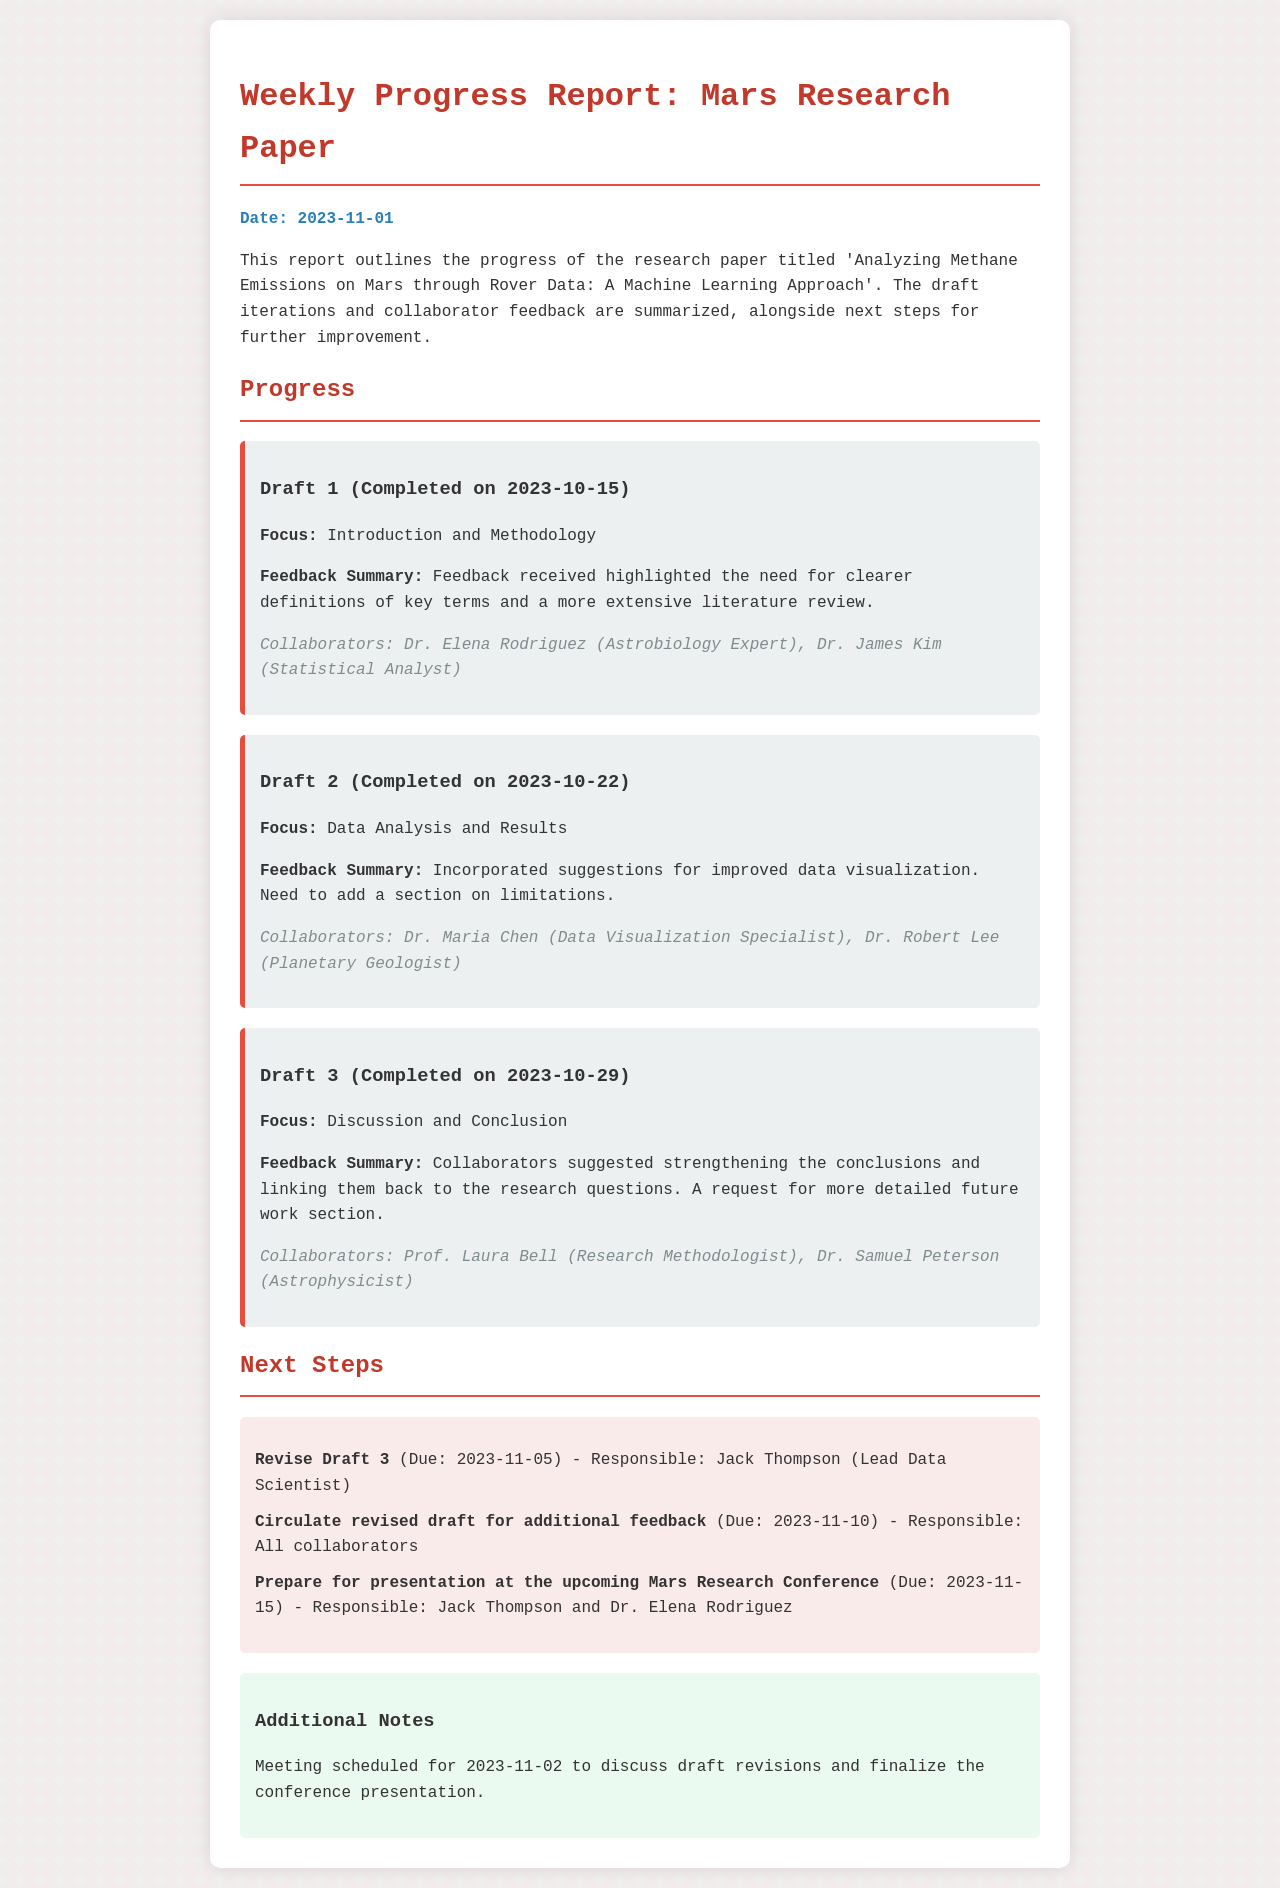What is the title of the research paper? The title is explicitly mentioned at the beginning of the report, which is 'Analyzing Methane Emissions on Mars through Rover Data: A Machine Learning Approach'.
Answer: Analyzing Methane Emissions on Mars through Rover Data: A Machine Learning Approach Who is responsible for revising Draft 3? The responsibility for revising Draft 3 is assigned to Jack Thompson, as noted in the next steps section of the report.
Answer: Jack Thompson What is the due date for the circulation of the revised draft? The due date for circulating the revised draft for additional feedback is clearly stated in the next steps section as November 10, 2023.
Answer: 2023-11-10 Which collaborator provided feedback on Draft 2? Dr. Maria Chen is specifically mentioned as a collaborator who gave feedback on Draft 2 regarding data visualization improvements.
Answer: Dr. Maria Chen What focus area does Draft 1 cover? The focus area of Draft 1 is provided directly in the report, indicating that it covers Introduction and Methodology.
Answer: Introduction and Methodology What was one suggestion made for Draft 3? The report indicates that one of the suggestions for Draft 3 was to strengthen the conclusions and link them back to the research questions.
Answer: Strengthen the conclusions When is the meeting scheduled to discuss draft revisions? The specific date of the meeting to discuss draft revisions is mentioned as November 2, 2023.
Answer: 2023-11-02 Who are the collaborators for Draft 1? The collaborators for Draft 1 are listed in the report, specifically Dr. Elena Rodriguez and Dr. James Kim.
Answer: Dr. Elena Rodriguez, Dr. James Kim What needs to be added to Draft 2 according to feedback? Feedback for Draft 2 suggests adding a section on limitations, as stated in the feedback summary.
Answer: Section on limitations 